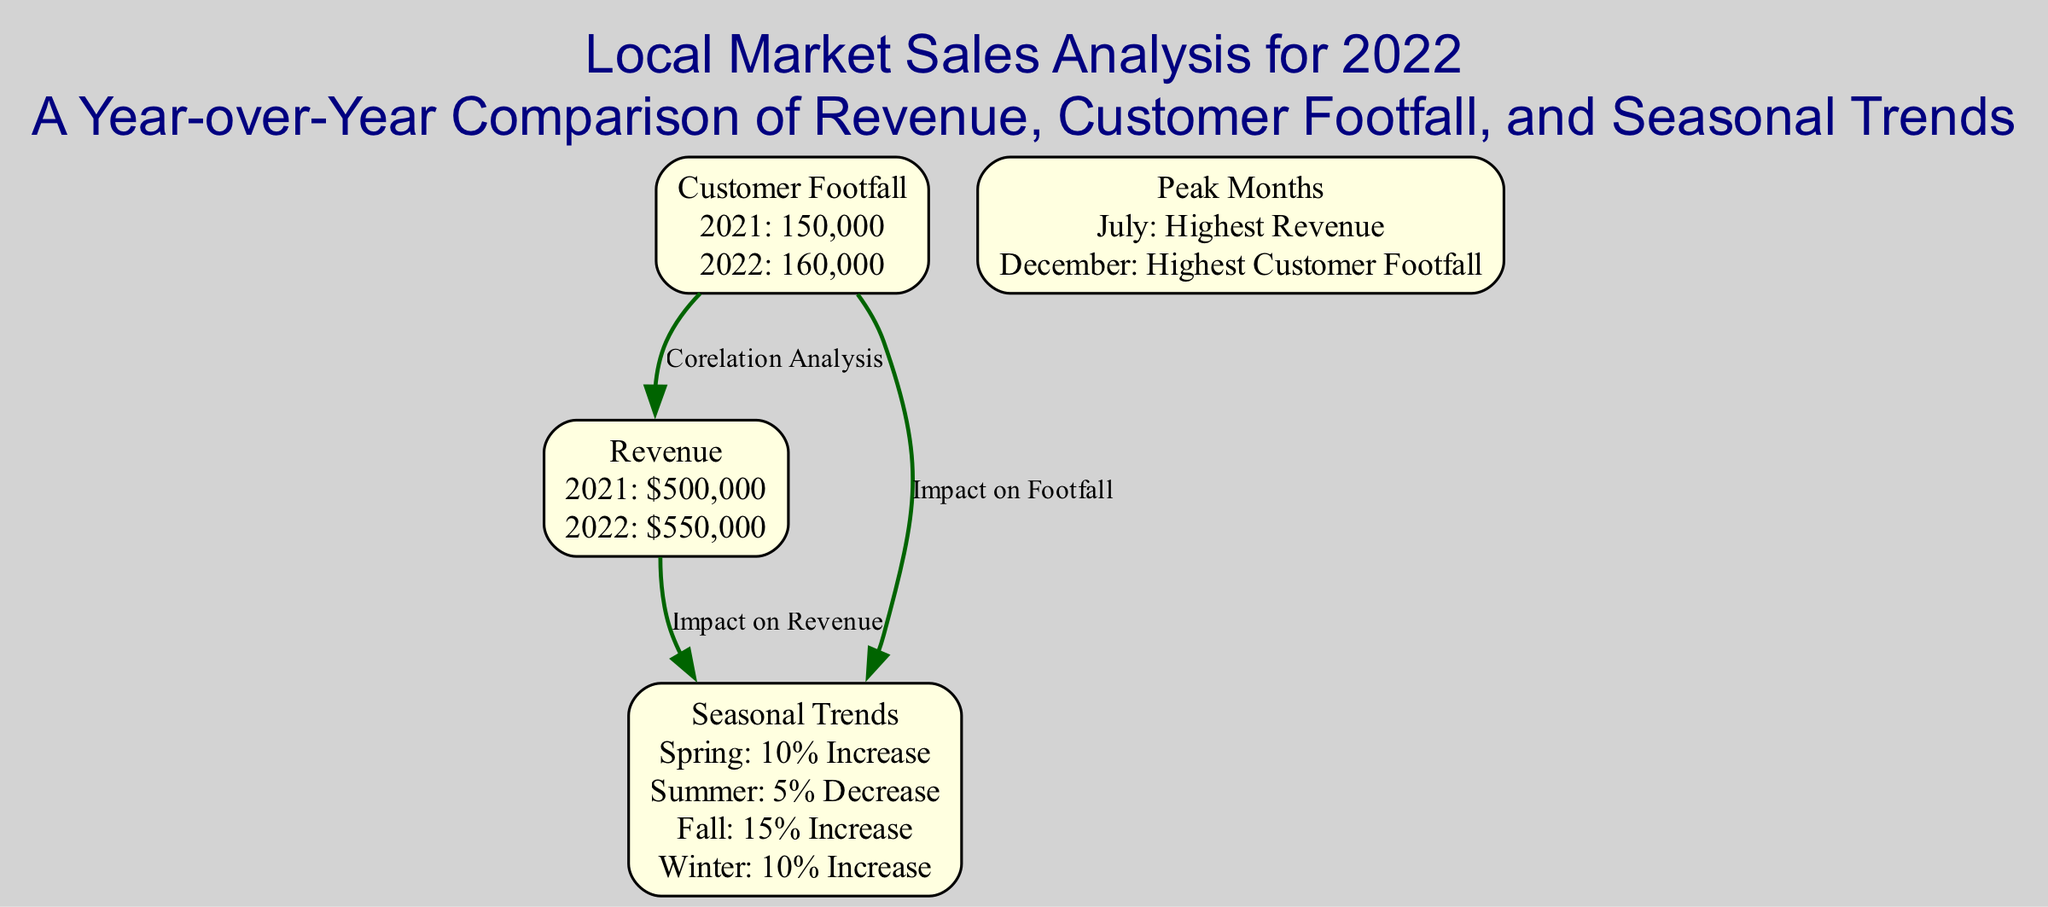What was the revenue for 2022? The diagram shows the revenue for 2022 indicated under the "Revenue" node, which states it to be $550,000.
Answer: $550,000 What was the customer footfall in 2021? The "Customer Footfall" node indicates the year 2021's footfall is 150,000, as noted in the details of that node.
Answer: 150,000 Which season had the highest increase in revenue? Referring to the "Seasonal Trends" node, the Spring season shows a 10% increase, which is the highest compared to other seasons listed.
Answer: Spring How many nodes are present in the diagram? Counting the number of nodes listed under "nodes," there are four nodes: revenue, customer footfall, seasonal trends, and peak months.
Answer: 4 What was the highest customer footfall month? The "Peak Months" node indicates December as having the highest customer footfall, clearly stated within that node's details.
Answer: December What impact does customer footfall have on revenue? The diagram shows a direct relationship between customer footfall and revenue by presenting an edge labeled "Corelation Analysis," indicating that customer footfall directly affects revenue.
Answer: Corelation Analysis Which season had the largest decrease in customer footfall? Looking at the "Seasonal Trends" node, the Summer season shows a 5% decrease, which is the sole decrease among the seasons listed, thus it is the largest decrease.
Answer: Summer What was the peak revenue month? The "Peak Months" node specifically states July as the month with the highest revenue, making it the peak month for revenue.
Answer: July How much did customer footfall increase from 2021 to 2022? To find the increase, we subtract 2021's customer footfall (150,000) from 2022's (160,000), resulting in a 10,000 increase.
Answer: 10,000 